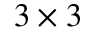Convert formula to latex. <formula><loc_0><loc_0><loc_500><loc_500>3 \times 3</formula> 